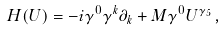<formula> <loc_0><loc_0><loc_500><loc_500>H ( U ) = - i \gamma ^ { 0 } \gamma ^ { k } \partial _ { k } + M \gamma ^ { 0 } U ^ { \gamma _ { 5 } } \, ,</formula> 